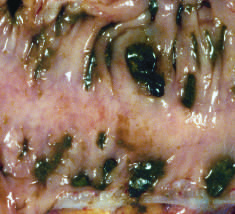does gross examination of a resected sigmoid colon show regularly spaced stool-filled diverticulae?
Answer the question using a single word or phrase. Yes 